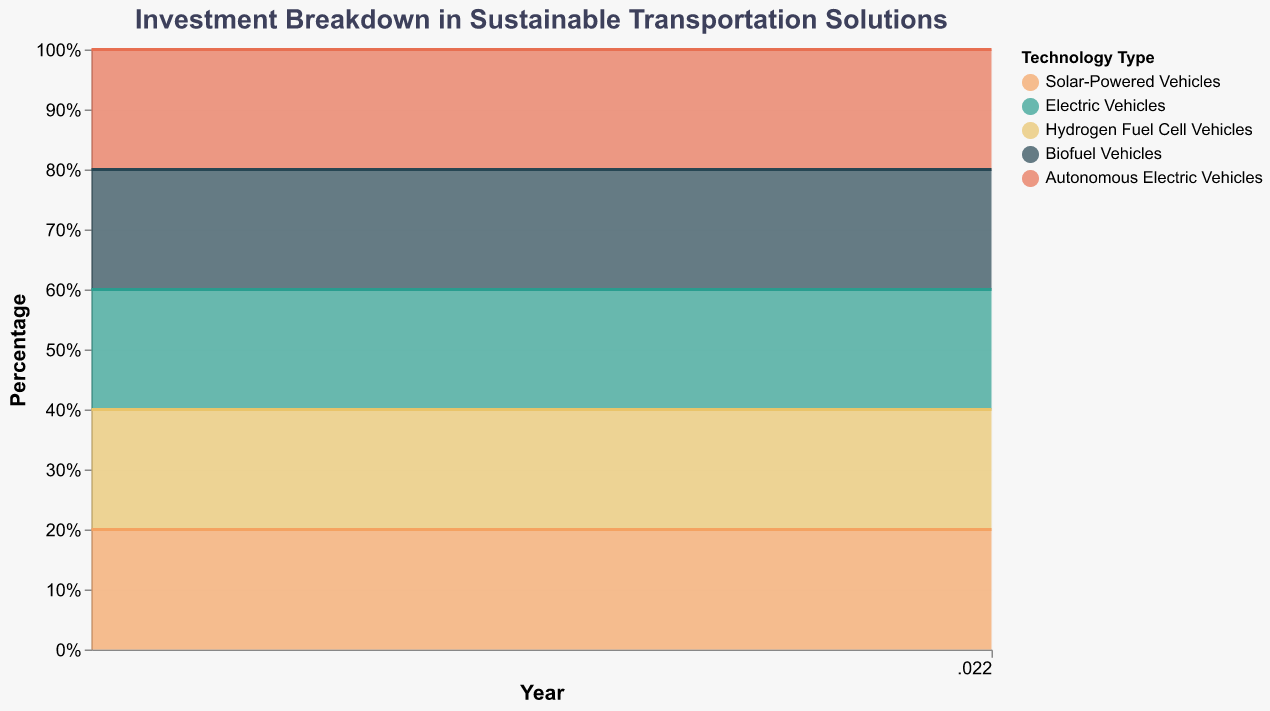What's the title of the chart? The title of the chart is located at the top and is in bold text. It is "Investment Breakdown in Sustainable Transportation Solutions".
Answer: Investment Breakdown in Sustainable Transportation Solutions Which technology type had the highest investment percentage in 2015? By looking at the height of the stacked areas for the year 2015, Electric Vehicles have the largest area, indicating they had the highest investment percentage.
Answer: Electric Vehicles How did the investment percentage in Solar-Powered Vehicles change from 2013 to 2022? Observing the area size of Solar-Powered Vehicles over the years, it increases from a small section to a larger one from 2013 to 2022. Specifically, it goes from 3% in 2013 to 14% in 2022.
Answer: Increased Which technology type had a decreasing investment trend over the past decade? By analyzing the areas, Biofuel Vehicles have a relatively stable but slightly decreasing trend, while Electric Vehicles have a more noticeable continuous decrease in their investment percentage from 2013 to 2022.
Answer: Electric Vehicles In which year did Autonomous Electric Vehicles have the highest investment percentage? Checking the height of the stacked area for Autonomous Electric Vehicles, their highest percentage investment is in 2022.
Answer: 2022 What was the investment percentage in Hydrogen Fuel Cell Vehicles in 2021? Refer to the height of the stacked area for Hydrogen Fuel Cell Vehicles at the year 2021, which appears to represent 31% of the total investment.
Answer: 31% Which technology type had the smallest change in investment percentage in the last decade? Comparing the areas’ size changes for each technology over the years, Biofuel Vehicles remained relatively constant, changing minimally.
Answer: Biofuel Vehicles What is the sum of the investment percentages in Electric Vehicles and Solar-Powered Vehicles for the year 2020? Check the respective areas for Electric Vehicles and Solar-Powered Vehicles in 2020 and add them together. Electric Vehicles are at 38% and Solar-Powered Vehicles at 11%. 38% + 11% = 49%.
Answer: 49% How did the total investment in Autonomous Electric Vehicles change from 2014 to 2018? Review the area representing Autonomous Electric Vehicles for these years, noting it grows from 9% in 2014 to 11% in 2018, indicating an increase.
Answer: Increased What is the average investment percentage in Biofuel Vehicles from 2013 to 2022? Calculate the mean of Biofuel Vehicles’ investment percentages over the years. The percentages are constant at 10% over all years. Thus, the average is (10% * 10)/10 = 10%.
Answer: 10% 